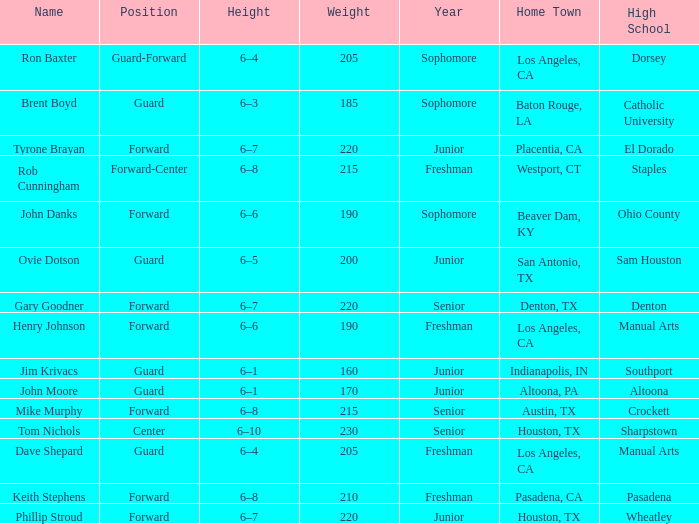What is the designation in a year with a beginner, and a weight greater than 210? Forward-Center. 